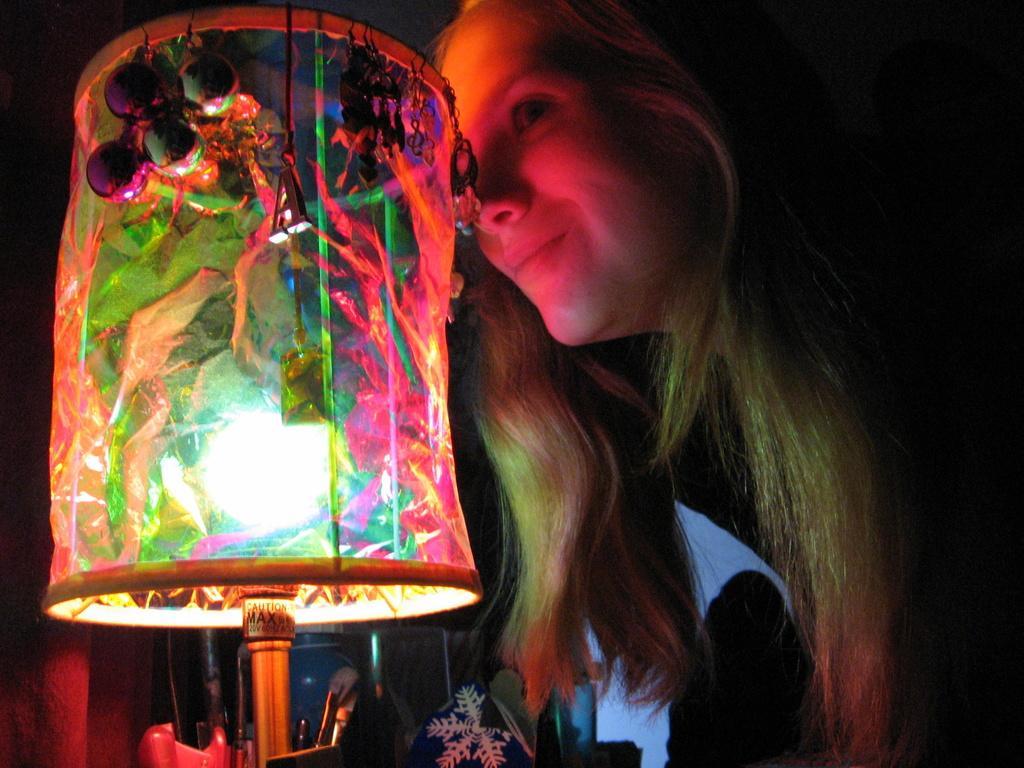Describe this image in one or two sentences. On the right side, there is a woman smiling and slightly bending in front of a light which is on the table on which, there are other objects. And the background is dark in color. 